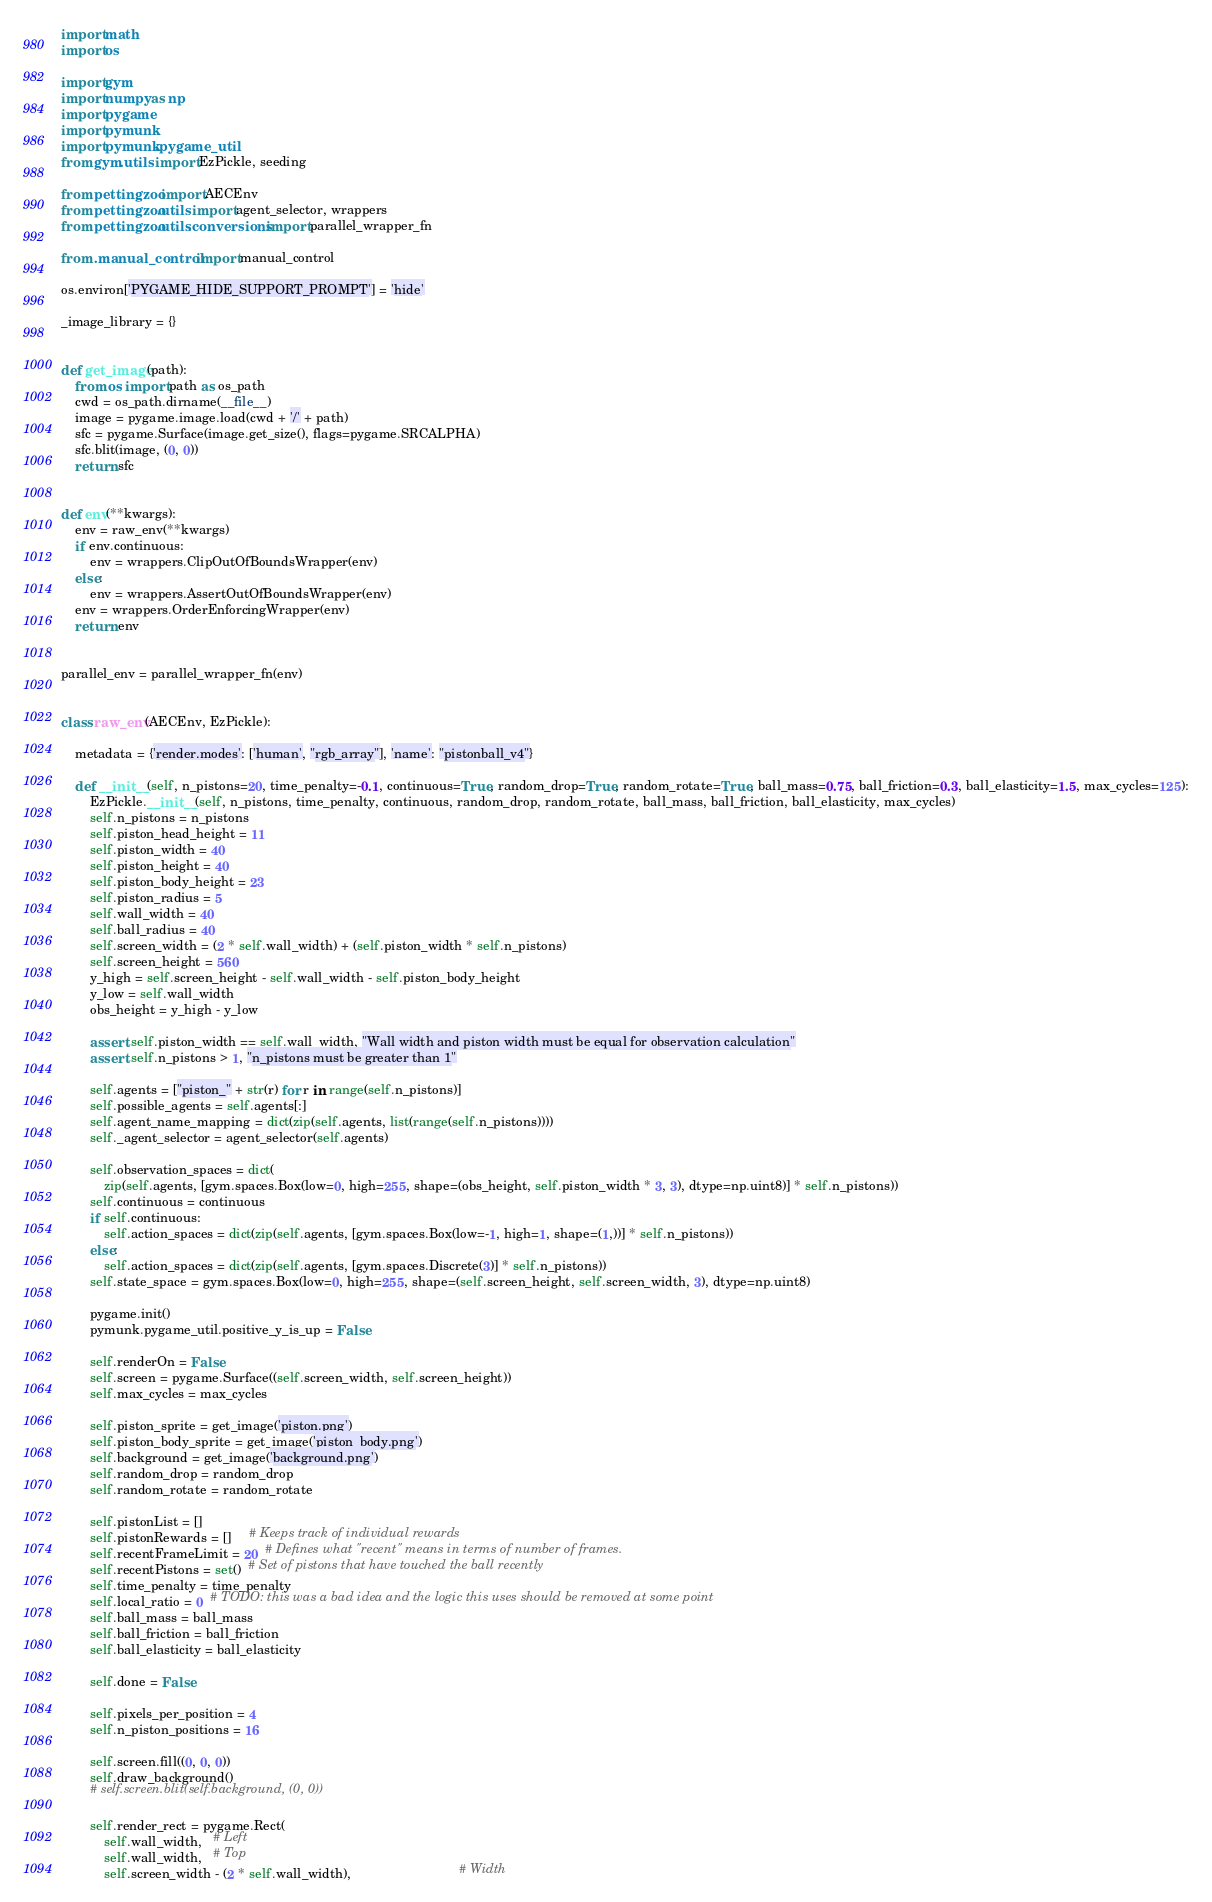Convert code to text. <code><loc_0><loc_0><loc_500><loc_500><_Python_>import math
import os

import gym
import numpy as np
import pygame
import pymunk
import pymunk.pygame_util
from gym.utils import EzPickle, seeding

from pettingzoo import AECEnv
from pettingzoo.utils import agent_selector, wrappers
from pettingzoo.utils.conversions import parallel_wrapper_fn

from .manual_control import manual_control

os.environ['PYGAME_HIDE_SUPPORT_PROMPT'] = 'hide'

_image_library = {}


def get_image(path):
    from os import path as os_path
    cwd = os_path.dirname(__file__)
    image = pygame.image.load(cwd + '/' + path)
    sfc = pygame.Surface(image.get_size(), flags=pygame.SRCALPHA)
    sfc.blit(image, (0, 0))
    return sfc


def env(**kwargs):
    env = raw_env(**kwargs)
    if env.continuous:
        env = wrappers.ClipOutOfBoundsWrapper(env)
    else:
        env = wrappers.AssertOutOfBoundsWrapper(env)
    env = wrappers.OrderEnforcingWrapper(env)
    return env


parallel_env = parallel_wrapper_fn(env)


class raw_env(AECEnv, EzPickle):

    metadata = {'render.modes': ['human', "rgb_array"], 'name': "pistonball_v4"}

    def __init__(self, n_pistons=20, time_penalty=-0.1, continuous=True, random_drop=True, random_rotate=True, ball_mass=0.75, ball_friction=0.3, ball_elasticity=1.5, max_cycles=125):
        EzPickle.__init__(self, n_pistons, time_penalty, continuous, random_drop, random_rotate, ball_mass, ball_friction, ball_elasticity, max_cycles)
        self.n_pistons = n_pistons
        self.piston_head_height = 11
        self.piston_width = 40
        self.piston_height = 40
        self.piston_body_height = 23
        self.piston_radius = 5
        self.wall_width = 40
        self.ball_radius = 40
        self.screen_width = (2 * self.wall_width) + (self.piston_width * self.n_pistons)
        self.screen_height = 560
        y_high = self.screen_height - self.wall_width - self.piston_body_height
        y_low = self.wall_width
        obs_height = y_high - y_low

        assert self.piston_width == self.wall_width, "Wall width and piston width must be equal for observation calculation"
        assert self.n_pistons > 1, "n_pistons must be greater than 1"

        self.agents = ["piston_" + str(r) for r in range(self.n_pistons)]
        self.possible_agents = self.agents[:]
        self.agent_name_mapping = dict(zip(self.agents, list(range(self.n_pistons))))
        self._agent_selector = agent_selector(self.agents)

        self.observation_spaces = dict(
            zip(self.agents, [gym.spaces.Box(low=0, high=255, shape=(obs_height, self.piston_width * 3, 3), dtype=np.uint8)] * self.n_pistons))
        self.continuous = continuous
        if self.continuous:
            self.action_spaces = dict(zip(self.agents, [gym.spaces.Box(low=-1, high=1, shape=(1,))] * self.n_pistons))
        else:
            self.action_spaces = dict(zip(self.agents, [gym.spaces.Discrete(3)] * self.n_pistons))
        self.state_space = gym.spaces.Box(low=0, high=255, shape=(self.screen_height, self.screen_width, 3), dtype=np.uint8)

        pygame.init()
        pymunk.pygame_util.positive_y_is_up = False

        self.renderOn = False
        self.screen = pygame.Surface((self.screen_width, self.screen_height))
        self.max_cycles = max_cycles

        self.piston_sprite = get_image('piston.png')
        self.piston_body_sprite = get_image('piston_body.png')
        self.background = get_image('background.png')
        self.random_drop = random_drop
        self.random_rotate = random_rotate

        self.pistonList = []
        self.pistonRewards = []     # Keeps track of individual rewards
        self.recentFrameLimit = 20  # Defines what "recent" means in terms of number of frames.
        self.recentPistons = set()  # Set of pistons that have touched the ball recently
        self.time_penalty = time_penalty
        self.local_ratio = 0  # TODO: this was a bad idea and the logic this uses should be removed at some point
        self.ball_mass = ball_mass
        self.ball_friction = ball_friction
        self.ball_elasticity = ball_elasticity

        self.done = False

        self.pixels_per_position = 4
        self.n_piston_positions = 16

        self.screen.fill((0, 0, 0))
        self.draw_background()
        # self.screen.blit(self.background, (0, 0))

        self.render_rect = pygame.Rect(
            self.wall_width,   # Left
            self.wall_width,   # Top
            self.screen_width - (2 * self.wall_width),                              # Width</code> 